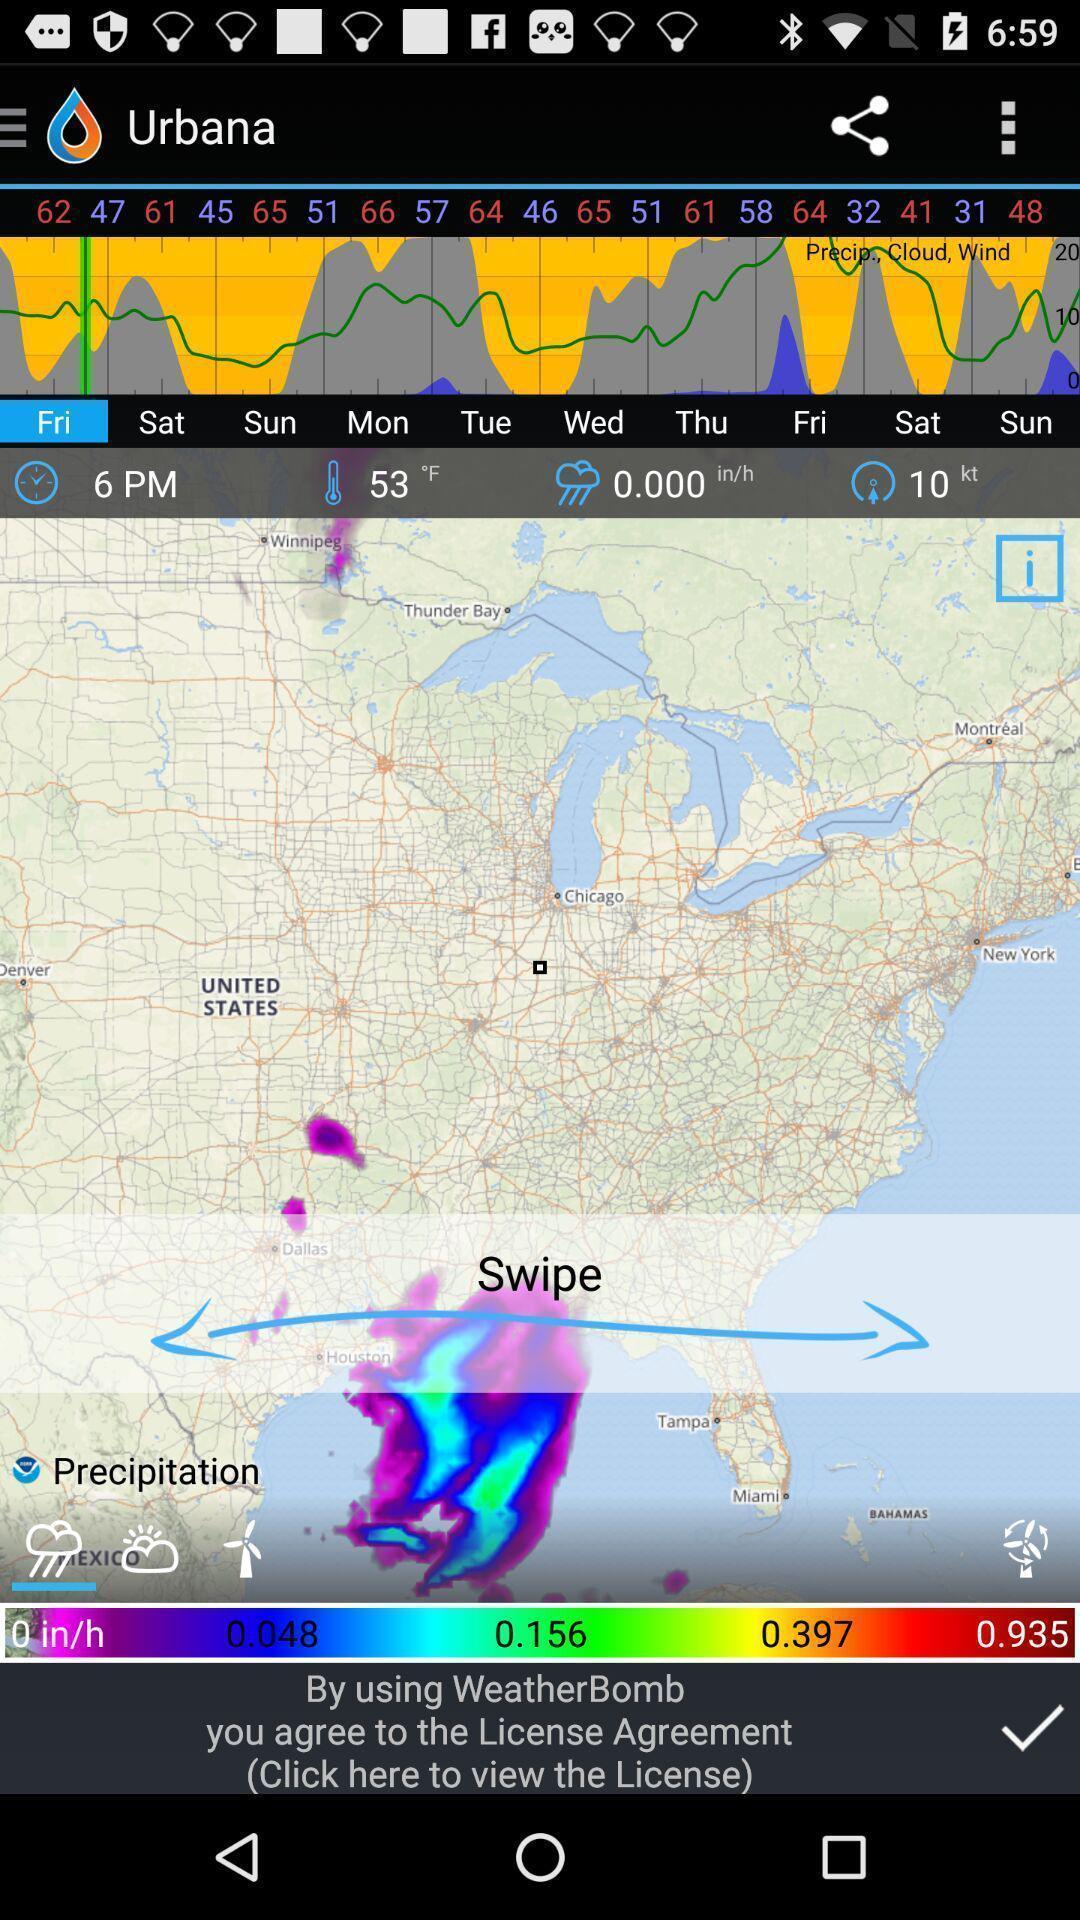Provide a description of this screenshot. Screen displaying weather map and graphs. 